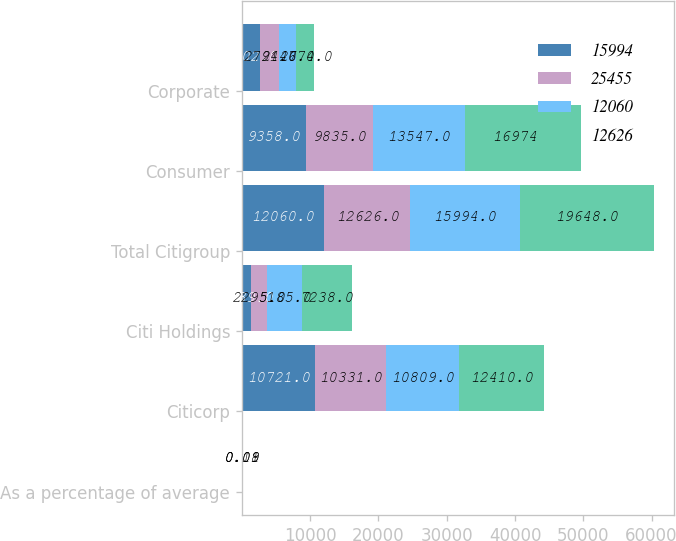Convert chart to OTSL. <chart><loc_0><loc_0><loc_500><loc_500><stacked_bar_chart><ecel><fcel>As a percentage of average<fcel>Citicorp<fcel>Citi Holdings<fcel>Total Citigroup<fcel>Consumer<fcel>Corporate<nl><fcel>15994<fcel>0.17<fcel>10721<fcel>1339<fcel>12060<fcel>9358<fcel>2702<nl><fcel>25455<fcel>0.08<fcel>10331<fcel>2295<fcel>12626<fcel>9835<fcel>2791<nl><fcel>12060<fcel>0.11<fcel>10809<fcel>5185<fcel>15994<fcel>13547<fcel>2447<nl><fcel>12626<fcel>0.09<fcel>12410<fcel>7238<fcel>19648<fcel>16974<fcel>2674<nl></chart> 